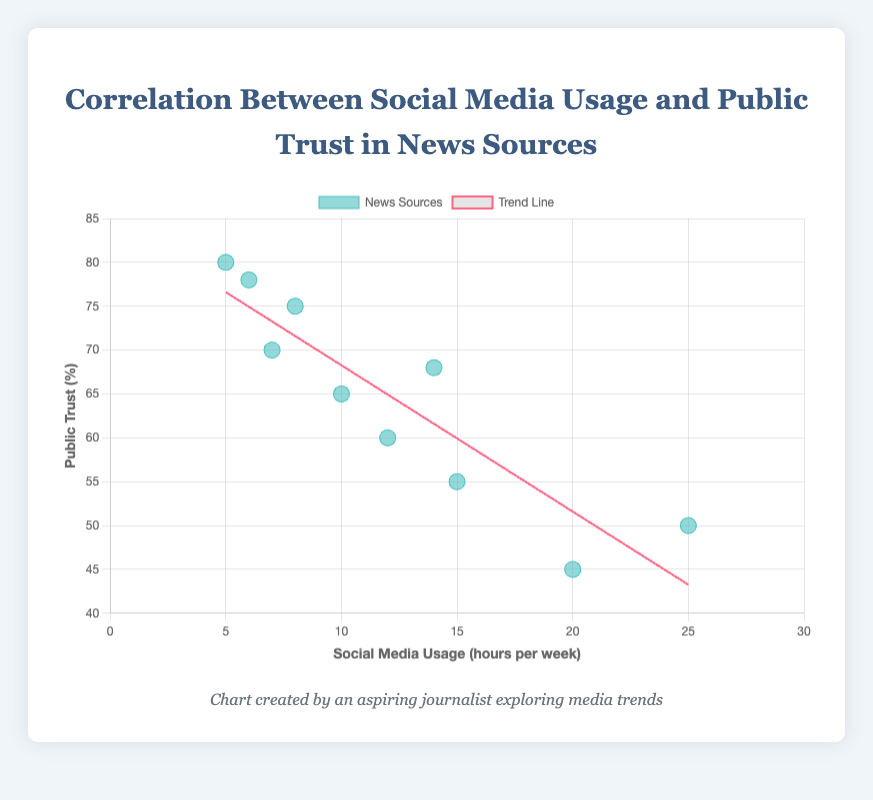what's the title of the scatter plot? The title of the scatter plot is mentioned at the top of the figure. It provides a summary of the data being visualized.
Answer: Correlation Between Social Media Usage and Public Trust in News Sources what are the labels of the x-axis and y-axis? The x-axis and y-axis labels describe what each axis represents. The x-axis represents "Social Media Usage (hours per week)," and the y-axis represents "Public Trust (%)."
Answer: Social Media Usage (hours per week) and Public Trust (%) how many data points are plotted in the scatter plot? By counting the distinct points on the scatter plot, we can determine the number of data points. Each data point represents the social media usage and public trust percentage for a different news source. There are 10 data points.
Answer: 10 which news source has the highest public trust percentage? By looking at the y-axis and finding the highest point, we can identify the news source with the highest public trust percentage. This value corresponds to a data point labeled "BBC."
Answer: BBC what is the public trust percentage for CNN? Locate the point representing CNN on the scatter plot. By checking its y-coordinate, we find the public trust percentage.
Answer: 65% does the trend line indicate a positive or negative correlation between social media usage and public trust? The trend line provides a visual representation of the correlation. If it slopes downward from left to right, the correlation is negative. The trend line in this plot slopes downwards, indicating a negative correlation.
Answer: Negative which news source has the highest social media usage hours per week but relatively low public trust percentage? Identify the point with the highest x-coordinate (social media usage hours per week) and check its y-coordinate (public trust percentage). BuzzFeed News falls under this category with 25 hours per week and a public trust of 50%.
Answer: BuzzFeed News what is the difference in public trust percentage between the news source with the highest and the lowest public trust? The highest public trust percentage is 80% (from BBC), and the lowest is 45% (from HuffPost). Subtract the lowest percentage from the highest to find the difference: 80% - 45%.
Answer: 35% what is the average social media usage hours per week across all news sources? Sum the social media usage hours per week for all news sources and divide by the number of data points (10). (5 + 10 + 15 + 7 + 20 + 12 + 8 + 25 + 6 + 14) / 10 = 12.2
Answer: 12.2 hours per week is the public trust percentage for The Guardian higher or lower than NPR? Compare the y-coordinates for the points representing The Guardian and NPR. The Guardian has a public trust percentage of 60%, while NPR has 78%. Therefore, The Guardian's percentage is lower.
Answer: Lower what is the general trend shown by the scatter plot with the trend line? The scatter plot and trend line illustrate how an increase in social media usage hours per week generally correlates with a decrease in public trust in the news sources.
Answer: Decrease in public trust with increasing social media usage 